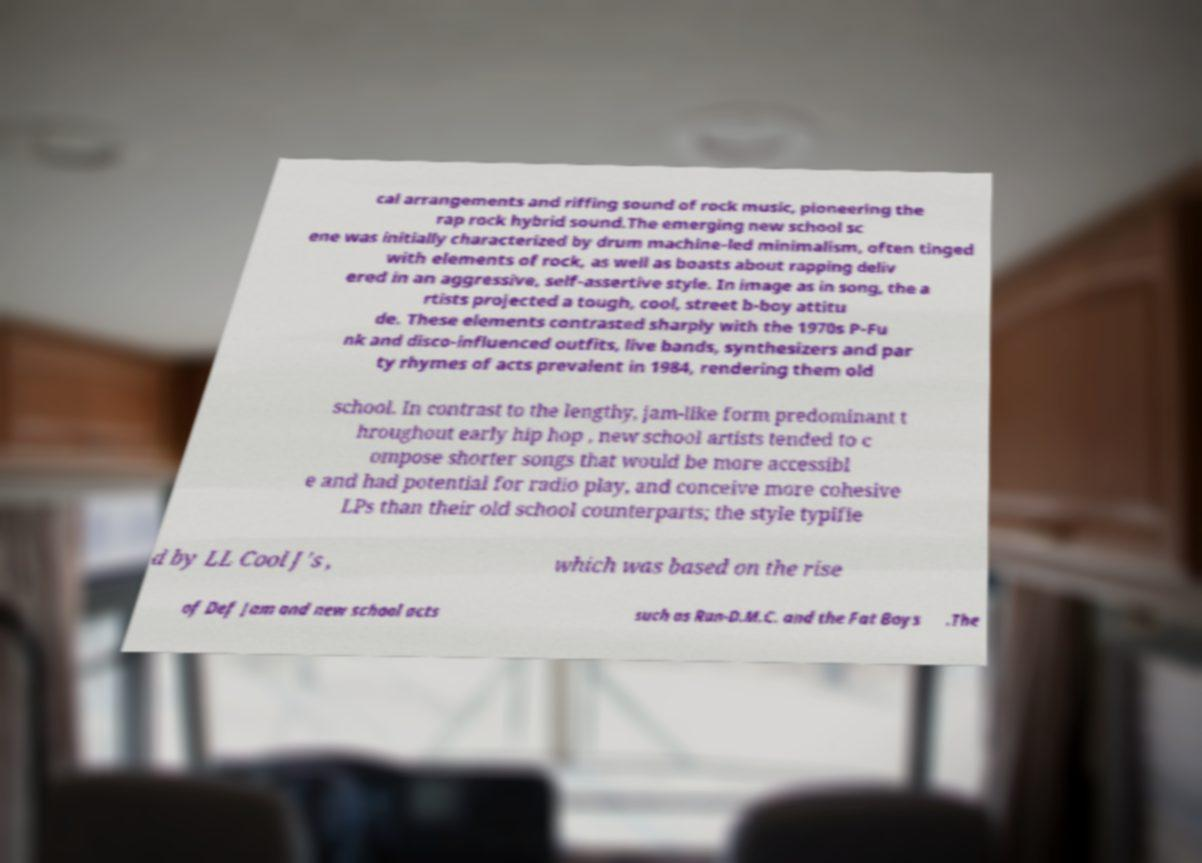Please identify and transcribe the text found in this image. cal arrangements and riffing sound of rock music, pioneering the rap rock hybrid sound.The emerging new school sc ene was initially characterized by drum machine-led minimalism, often tinged with elements of rock, as well as boasts about rapping deliv ered in an aggressive, self-assertive style. In image as in song, the a rtists projected a tough, cool, street b-boy attitu de. These elements contrasted sharply with the 1970s P-Fu nk and disco-influenced outfits, live bands, synthesizers and par ty rhymes of acts prevalent in 1984, rendering them old school. In contrast to the lengthy, jam-like form predominant t hroughout early hip hop , new school artists tended to c ompose shorter songs that would be more accessibl e and had potential for radio play, and conceive more cohesive LPs than their old school counterparts; the style typifie d by LL Cool J's , which was based on the rise of Def Jam and new school acts such as Run-D.M.C. and the Fat Boys .The 